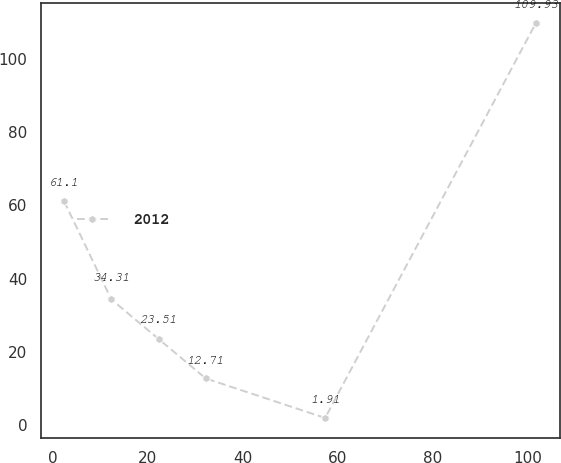<chart> <loc_0><loc_0><loc_500><loc_500><line_chart><ecel><fcel>2012<nl><fcel>2.38<fcel>61.1<nl><fcel>12.32<fcel>34.31<nl><fcel>22.26<fcel>23.51<nl><fcel>32.2<fcel>12.71<nl><fcel>57.35<fcel>1.91<nl><fcel>101.78<fcel>109.93<nl></chart> 